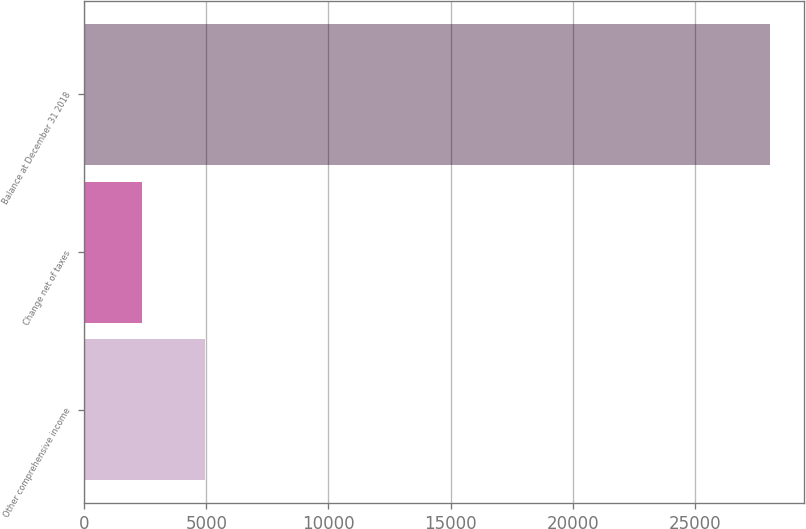<chart> <loc_0><loc_0><loc_500><loc_500><bar_chart><fcel>Other comprehensive income<fcel>Change net of taxes<fcel>Balance at December 31 2018<nl><fcel>4932.8<fcel>2362<fcel>28070<nl></chart> 